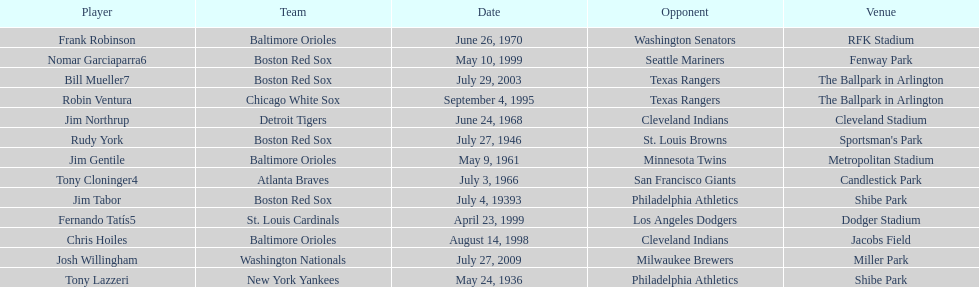What was the name of the player who accomplished this in 1999 but played for the boston red sox? Nomar Garciaparra. 